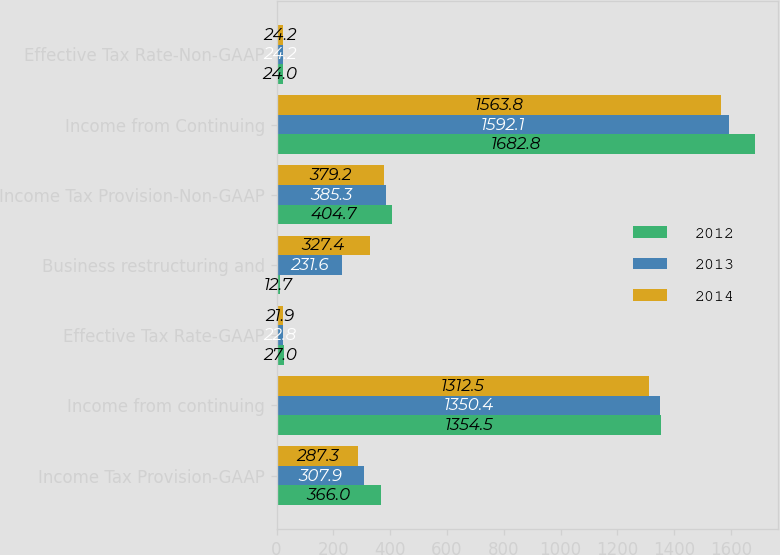Convert chart to OTSL. <chart><loc_0><loc_0><loc_500><loc_500><stacked_bar_chart><ecel><fcel>Income Tax Provision-GAAP<fcel>Income from continuing<fcel>Effective Tax Rate-GAAP<fcel>Business restructuring and<fcel>Income Tax Provision-Non-GAAP<fcel>Income from Continuing<fcel>Effective Tax Rate-Non-GAAP<nl><fcel>2012<fcel>366<fcel>1354.5<fcel>27<fcel>12.7<fcel>404.7<fcel>1682.8<fcel>24<nl><fcel>2013<fcel>307.9<fcel>1350.4<fcel>22.8<fcel>231.6<fcel>385.3<fcel>1592.1<fcel>24.2<nl><fcel>2014<fcel>287.3<fcel>1312.5<fcel>21.9<fcel>327.4<fcel>379.2<fcel>1563.8<fcel>24.2<nl></chart> 